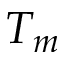<formula> <loc_0><loc_0><loc_500><loc_500>T _ { m }</formula> 